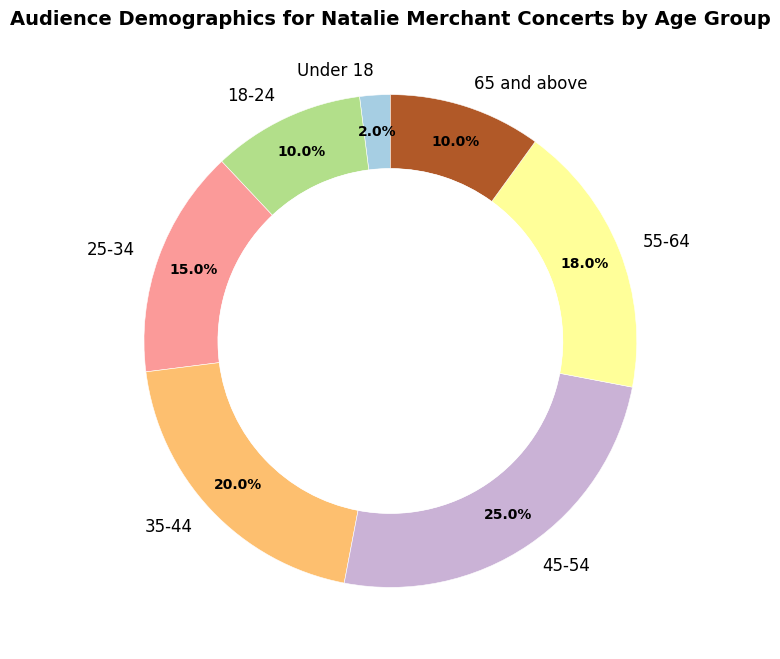What's the largest age group in the audience? The ring chart visually shows that the '45-54' age group occupies the largest segment. This group has a percentage of 25%, which is more than any other age group in the chart.
Answer: 45-54 Which age groups constitute a quarter of the audience combined? To constitute a quarter of the audience, we need to reach 25%. Adding the 'Under 18' (2%) and '18-24' (10%) groups together equals 12%. Adding '25-34' (15%) totals 27%, which exceeds 25%. Therefore, 'Under 18' and '18-24' combined make about a quarter.
Answer: Under 18 and 18-24 What's the combined percentage of people aged 45 and above? Sum the percentages of the age groups '45-54' (25%), '55-64' (18%), and '65 and above' (10%). The total is 25 + 18 + 10 = 53%.
Answer: 53% How does the percentage of the '25-34' group compare to that of the '55-64' group? The chart shows '25-34' at 15% and '55-64' at 18%. Comparing the two, the '55-64' group's percentage is 3% higher than the '25-34' group's.
Answer: 55-64 is 3% higher What is the percentage difference between the '45-54' and '18-24' age groups? The percentage for '45-54' is 25%, and for '18-24' it's 10%. The difference between them is 25 - 10 = 15%.
Answer: 15% Which age group has the smallest segment? The segment with the smallest percentage is 'Under 18' with 2%, as shown in the chart.
Answer: Under 18 What is the average percentage of the '35-44', '45-54', and '55-64' age groups? Sum the percentages of the '35-44' (20%), '45-54' (25%), and '55-64' (18%) groups, which equals 20 + 25 + 18 = 63%. Divide this by 3 to get the average: 63 / 3 = 21%.
Answer: 21% Can you identify the age groups that make up more than 15% of the audience individually? The age groups that individually make up more than 15% are '35-44' (20%), '45-54' (25%), and '55-64' (18%).
Answer: 35-44, 45-54, and 55-64 Which two age groups together have a similar combined percentage to the '45-54' group? The '45-54' group has 25%. Adding the '18-24' (10%) and '35-44' (20%) groups together totals 10 + 20 = 30%, which is close. Alternatively, '25-34' (15%) and '55-64' (18%) sum up to 33%, which is also relatively close.
Answer: 18-24 and 35-44 or 25-34 and 55-64 What is the median age group in terms of audience percentage? To find the median, order the age groups by percentage: 2, 10, 10, 15, 18, 20, 25. The middle value in this ordered list is 15%. So the '25-34' age group represents the median.
Answer: 25-34 